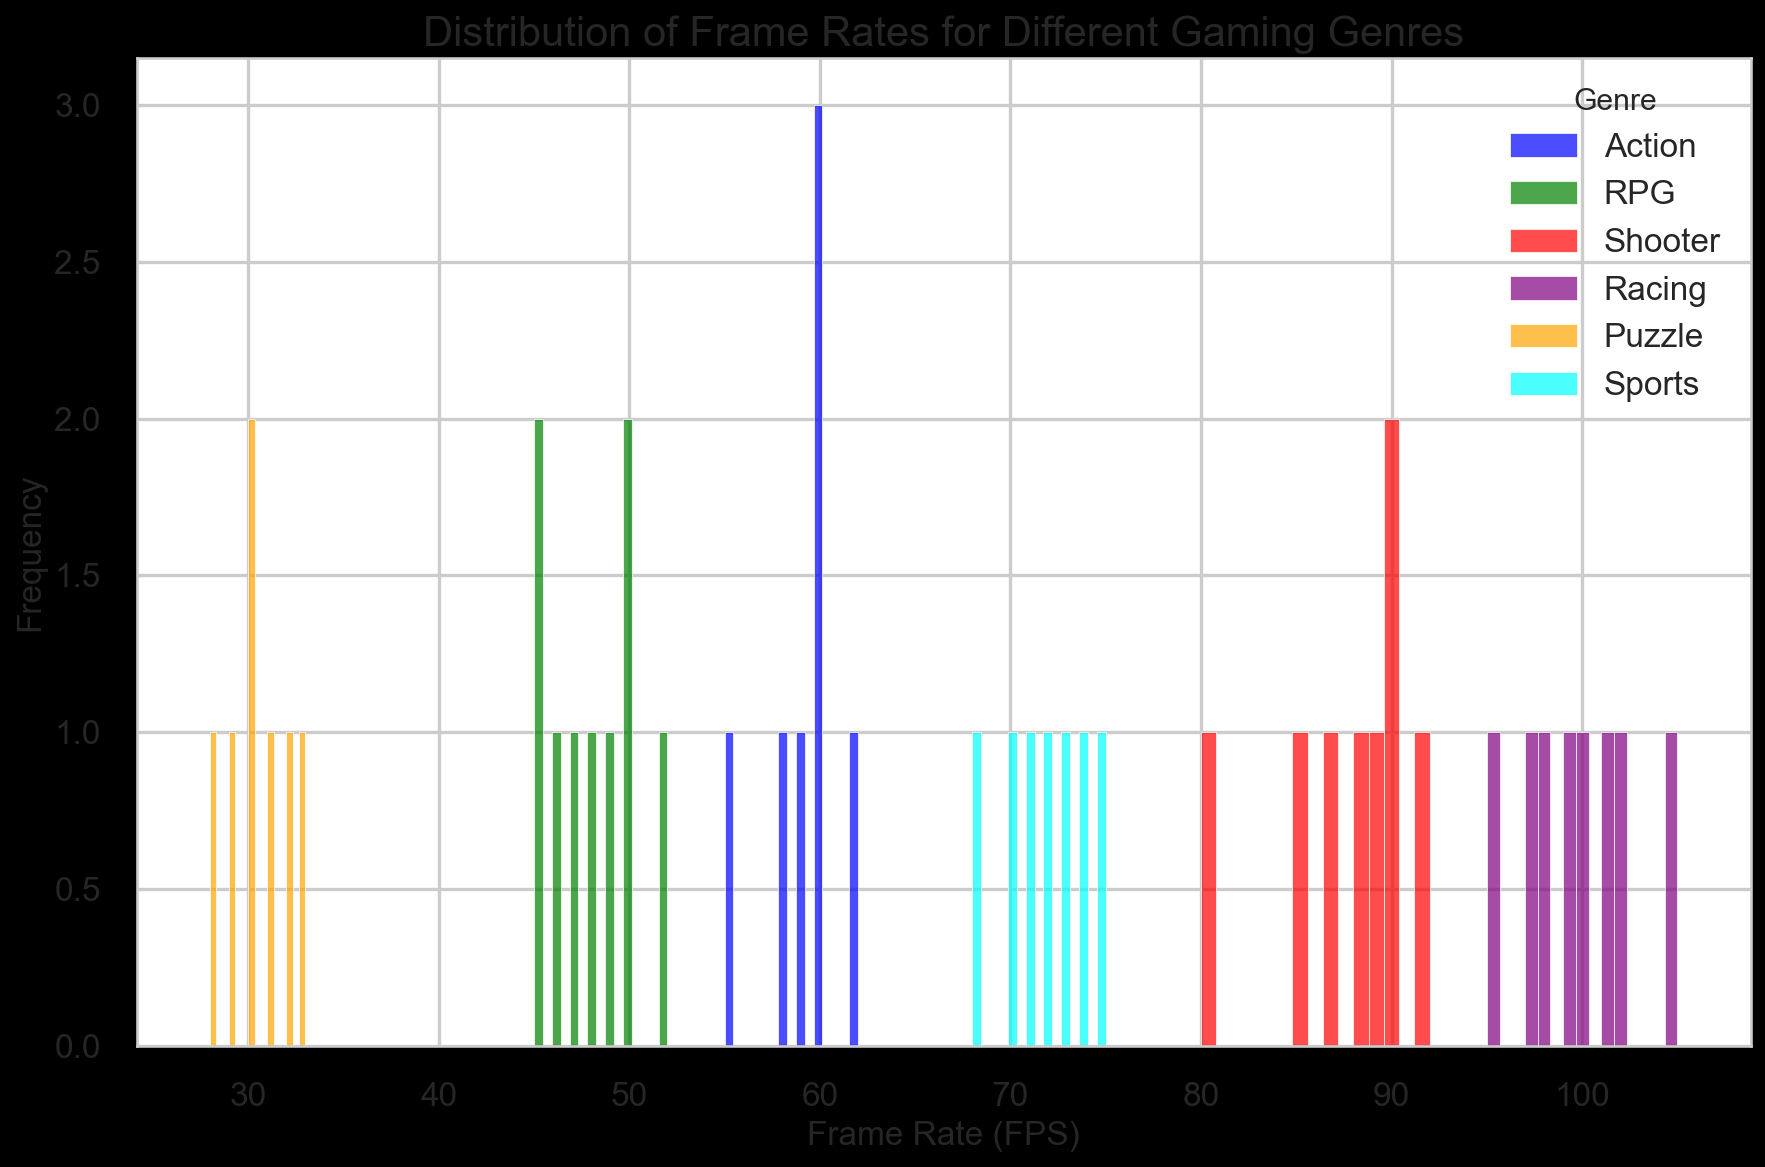What gaming genre has the widest range of frame rates? To determine the widest range, we need to look at the lowest and highest frame rates within each genre. The Racing genre has frame rates ranging from 95 to 105, indicating the widest range.
Answer: Racing Which genre appears to have the highest peak frequency in the histogram? To identify the genre with the highest peak frequency, observe the highest single bar in the plot. The Action genre, with a peak around 60 FPS, appears to have the highest frequency.
Answer: Action What is the average frame rate for the RPG genre? To find the average, calculate the sum of the frame rates for the RPG genre and divide by the number of data points. The sum is 45 + 50 + 47 + 48 + 46 + 49 + 45 + 50 + 52 = 432, and there are 9 data points. So, 432 / 9 = 48.
Answer: 48 Which genre has frame rates falling primarily in the 80-100 range? By observing the histogram, the Shooter genre predominantly has frame rates within the 80-100 FPS range.
Answer: Shooter Compare the median frame rates between the Sports and Puzzle genres. Which is higher? To find the median frame rate, arrange the data in ascending order and find the middle value. For Sports: [68, 70, 71, 72, 73, 74, 75], the median is 72. For Puzzle: [28, 29, 30, 30, 31, 32, 33], the median is 30. Therefore, the median frame rate is higher for the Sports genre.
Answer: Sports Which color in the histogram represents the Racing genre? The Racing genre is represented by the color purple in the histogram, as specified in the color mapping.
Answer: Purple Are there any genres that do not overlap in their frame rate distributions? If so, which ones? By examining the histogram, the Puzzle genre (28-33 FPS) and the Racing genre (95-105 FPS) do not overlap in their frame rate distributions.
Answer: Puzzle and Racing What is the primary frame rate range for the Action genre? The histogram shows that the Action genre primarily has frame rates ranging from approximately 55 to 62 FPS.
Answer: 55-62 Is the Shooting genre more consistent in frame rates compared to the RPG genre? Consistency can be assessed by the spread or range of the frame rates. The Shooting genre ranges from 80 to 92 FPS, whereas the RPG genre ranges from 45 to 52 FPS. The RPG genre has a smaller range, indicating more consistency.
Answer: RPG 